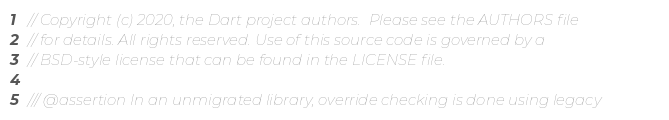<code> <loc_0><loc_0><loc_500><loc_500><_Dart_>// Copyright (c) 2020, the Dart project authors.  Please see the AUTHORS file
// for details. All rights reserved. Use of this source code is governed by a
// BSD-style license that can be found in the LICENSE file.

/// @assertion In an unmigrated library, override checking is done using legacy</code> 